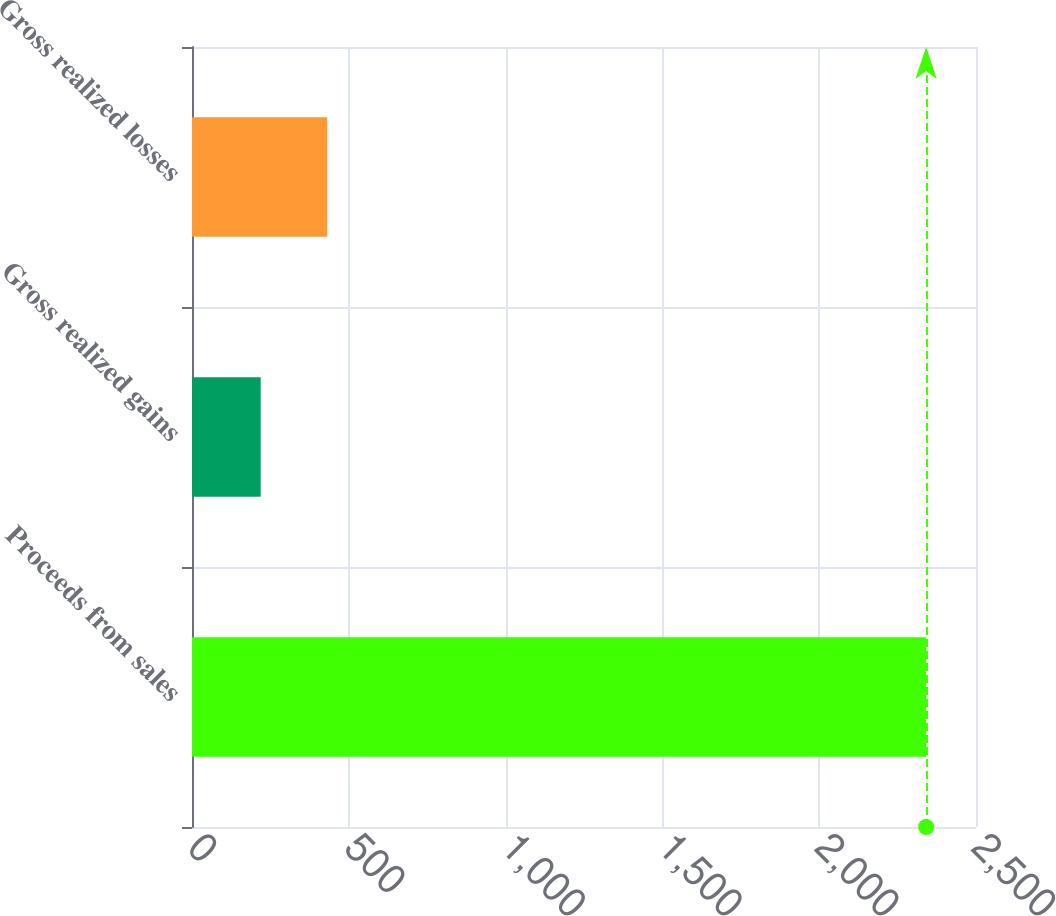<chart> <loc_0><loc_0><loc_500><loc_500><bar_chart><fcel>Proceeds from sales<fcel>Gross realized gains<fcel>Gross realized losses<nl><fcel>2341<fcel>219<fcel>431.2<nl></chart> 